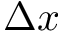<formula> <loc_0><loc_0><loc_500><loc_500>\Delta x</formula> 